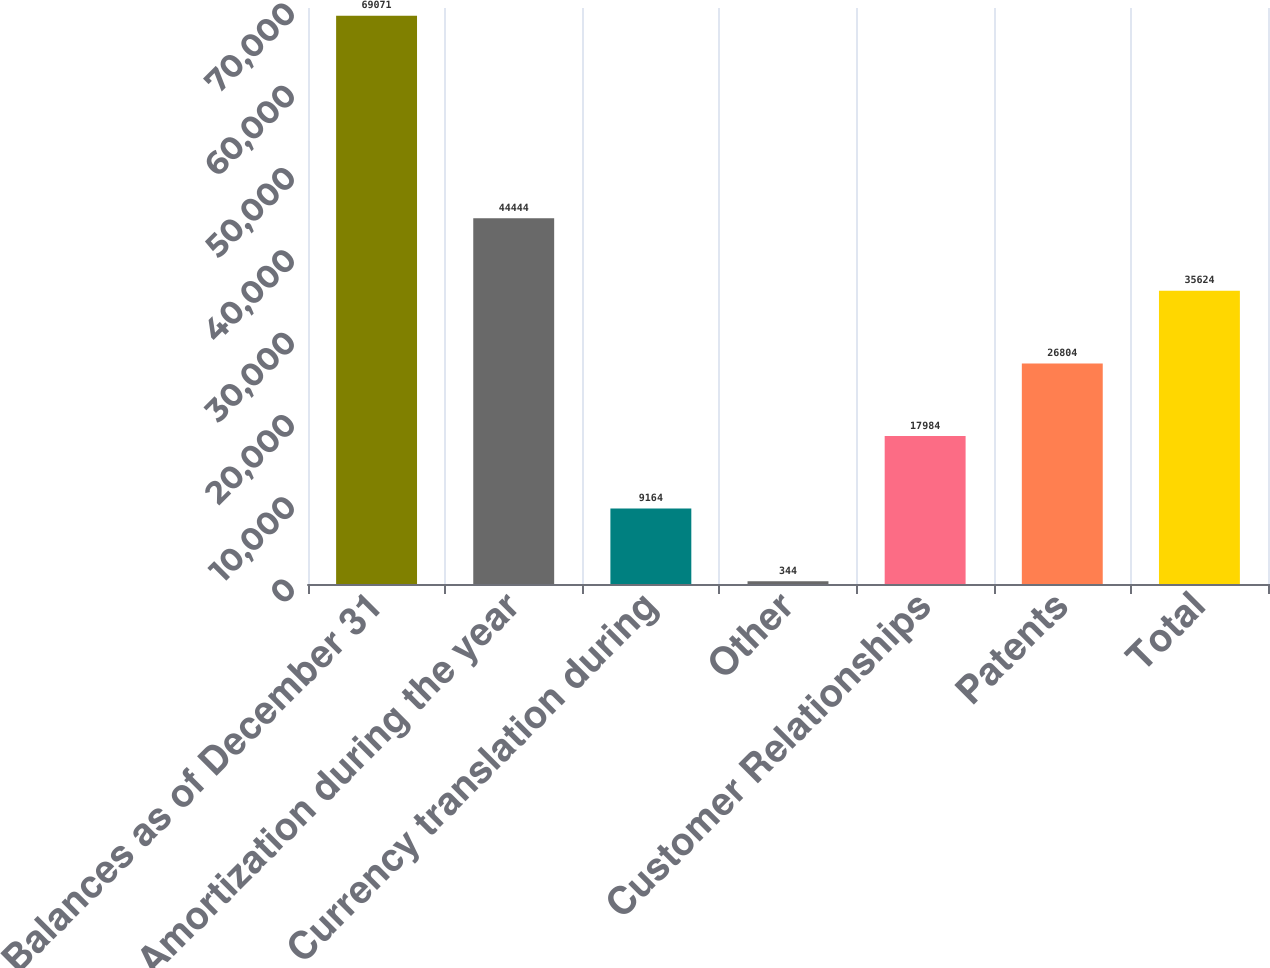Convert chart to OTSL. <chart><loc_0><loc_0><loc_500><loc_500><bar_chart><fcel>Balances as of December 31<fcel>Amortization during the year<fcel>Currency translation during<fcel>Other<fcel>Customer Relationships<fcel>Patents<fcel>Total<nl><fcel>69071<fcel>44444<fcel>9164<fcel>344<fcel>17984<fcel>26804<fcel>35624<nl></chart> 